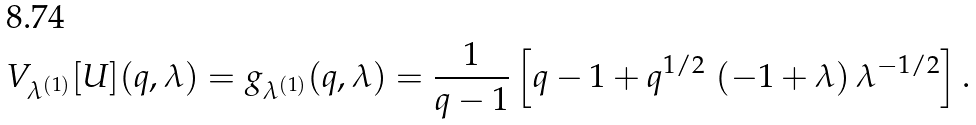<formula> <loc_0><loc_0><loc_500><loc_500>V _ { \lambda ^ { ( 1 ) } } [ U ] ( q , \lambda ) = g _ { \lambda ^ { ( 1 ) } } ( q , \lambda ) = \frac { 1 } { q - 1 } \left [ q - 1 + q ^ { 1 / 2 } \, \left ( - 1 + \lambda \right ) { \lambda } ^ { - 1 / 2 } \right ] .</formula> 